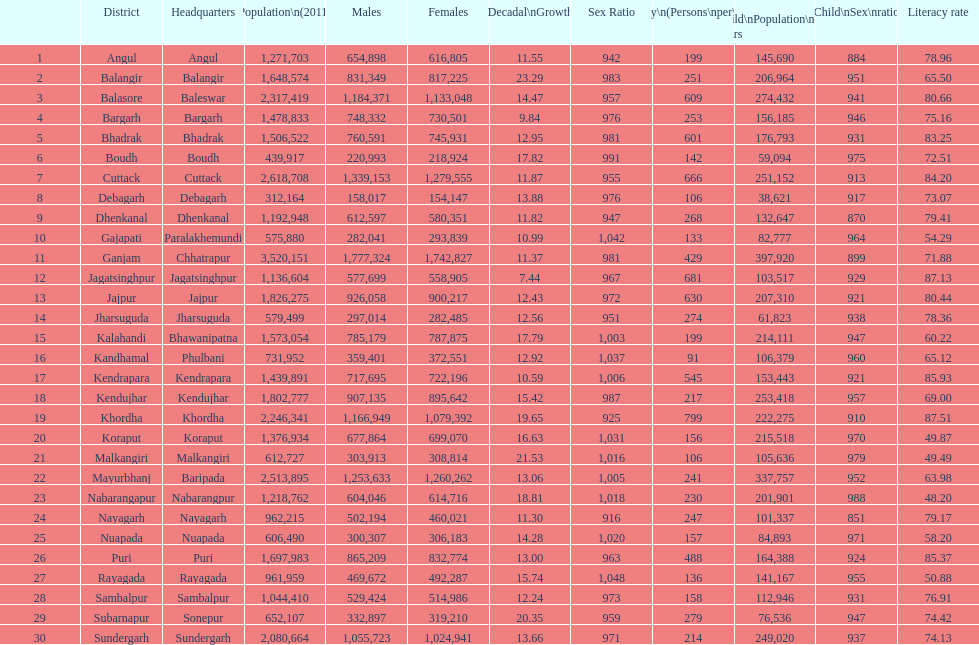How does the child population vary between koraput and puri? 51,130. 